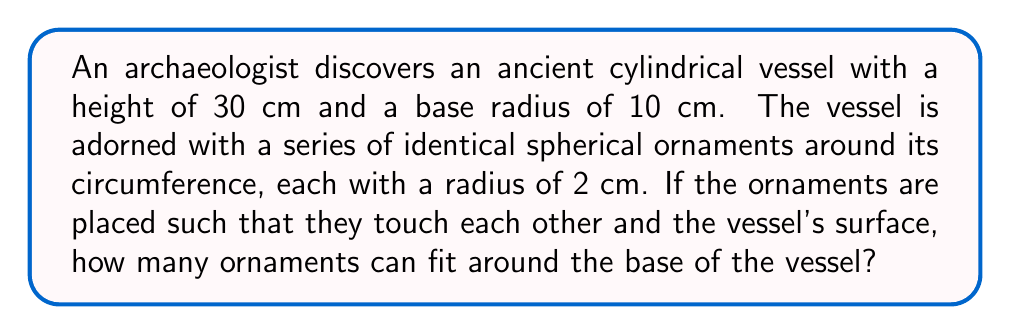Give your solution to this math problem. To solve this problem, we need to follow these steps:

1) First, we need to calculate the circumference of the base of the cylindrical vessel:
   $$C = 2\pi r$$
   where $r$ is the radius of the base.
   $$C = 2\pi (10\text{ cm}) = 20\pi\text{ cm}$$

2) Now, we need to determine the arc length that each spherical ornament occupies on the circumference. This is equal to the diameter of the ornament:
   $$d = 2r = 2(2\text{ cm}) = 4\text{ cm}$$

3) The number of ornaments that can fit around the base is the circumference divided by the diameter of each ornament:
   $$N = \frac{C}{d} = \frac{20\pi\text{ cm}}{4\text{ cm}} = 5\pi$$

4) Since we can only have a whole number of ornaments, we need to round down to the nearest integer:
   $$N = \lfloor 5\pi \rfloor = \lfloor 15.71 \rfloor = 15$$

Therefore, 15 spherical ornaments can fit around the base of the cylindrical vessel.

[asy]
import geometry;

unitsize(1cm);

// Draw the base of the cylinder
draw(circle((0,0),10));

// Draw the ornaments
for(int i=0; i<15; ++i) {
  real angle = 2*pi*i/15;
  pair center = 10*dir(angle);
  draw(circle(center, 2));
}

// Label
label("Top view", (0,-11));
[/asy]
Answer: 15 ornaments 